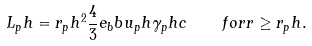<formula> <loc_0><loc_0><loc_500><loc_500>L _ { p } h = r _ { p } h ^ { 2 } \frac { 4 } { 3 } e _ { b } b u _ { p } h \gamma _ { p } h c \quad f o r r \geq r _ { p } h .</formula> 